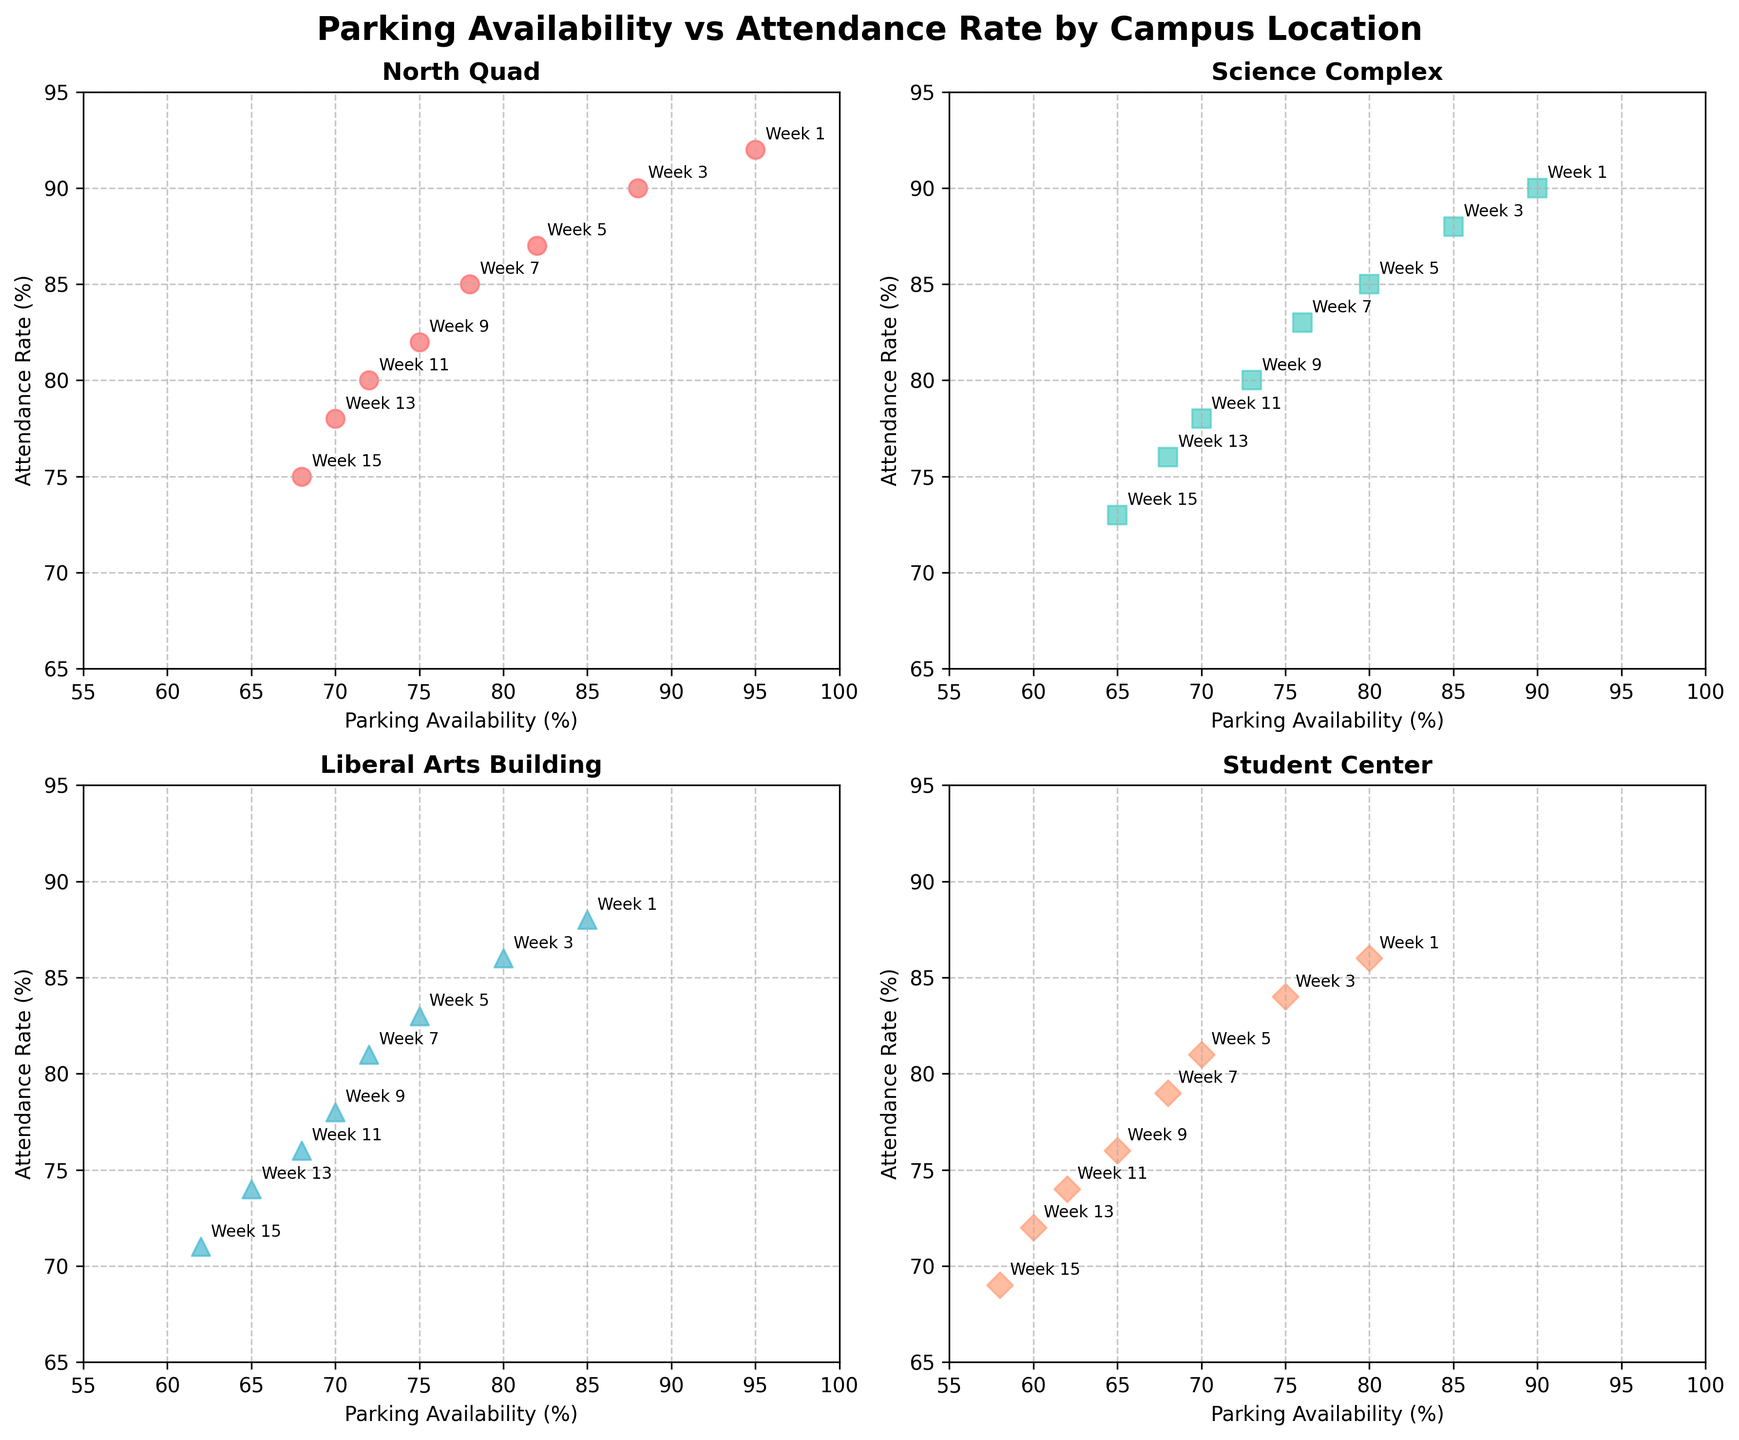What is the title of the figure? The title is usually located at the top center of the figure. In this case, it reads "Parking Availability vs Attendance Rate by Campus Location".
Answer: Parking Availability vs Attendance Rate by Campus Location How many subplots are there in the figure? The figure is divided into a 2x2 grid of subplots, so there are four subplots in total.
Answer: 4 Which campus location shows the highest attendance rate in Week 1? By analyzing each subplot, you can see that the 'North Quad' location shows an attendance rate of 92% in Week 1, which is the highest among all locations.
Answer: North Quad Is there a general trend for parking availability and attendance rate across all campus locations? The overall trend can be observed by comparing the scatter plots for all locations. As parking availability decreases from Week 1 to Week 15, the attendance rate also tends to decrease in all locations.
Answer: Both decrease Which campus location has the lowest parking availability in Week 15? The 'Student Center' subplot shows a parking availability of 58% in Week 15, which is the lowest among all locations.
Answer: Student Center Compare the attendance rate in Week 9 between 'North Quad' and 'Science Complex'. Which one is higher? Reviewing the 'North Quad' subplot, the attendance rate in Week 9 is 82%. In the 'Science Complex' subplot, it is 80%. Therefore, 'North Quad' has a higher attendance rate in Week 9.
Answer: North Quad How does the attendance rate change over the weeks in the 'Liberal Arts Building' subplot? In the 'Liberal Arts Building' subplot, attendance decreases consistently: Week 1 (88%), Week 3 (86%), Week 5 (83%), Week 7 (81%), Week 9 (78%), Week 11 (76%), Week 13 (74%), and Week 15 (71%).
Answer: Decreases consistently What is the difference in parking availability between Week 1 and Week 15 in the 'Science Complex'? From the 'Science Complex' subplot, the parking availability in Week 1 is 90% and in Week 15 it is 65%. The difference is 90% - 65% = 25%.
Answer: 25% Which location shows the steepest drop in attendance rate from Week 1 to Week 15? By comparing the slopes (difference in attendance rate) across all subplots, the 'Student Center' shows the steepest drop from 86% in Week 1 to 69% in Week 15, a difference of 86% - 69% = 17%.
Answer: Student Center What is the average attendance rate in 'North Quad' across all weeks? In 'North Quad', the attendance rates across the weeks are 92, 90, 87, 85, 82, 80, 78, and 75. The sum is 669, and there are 8 weeks, so the average is 669 / 8 = 83.625.
Answer: 83.625 